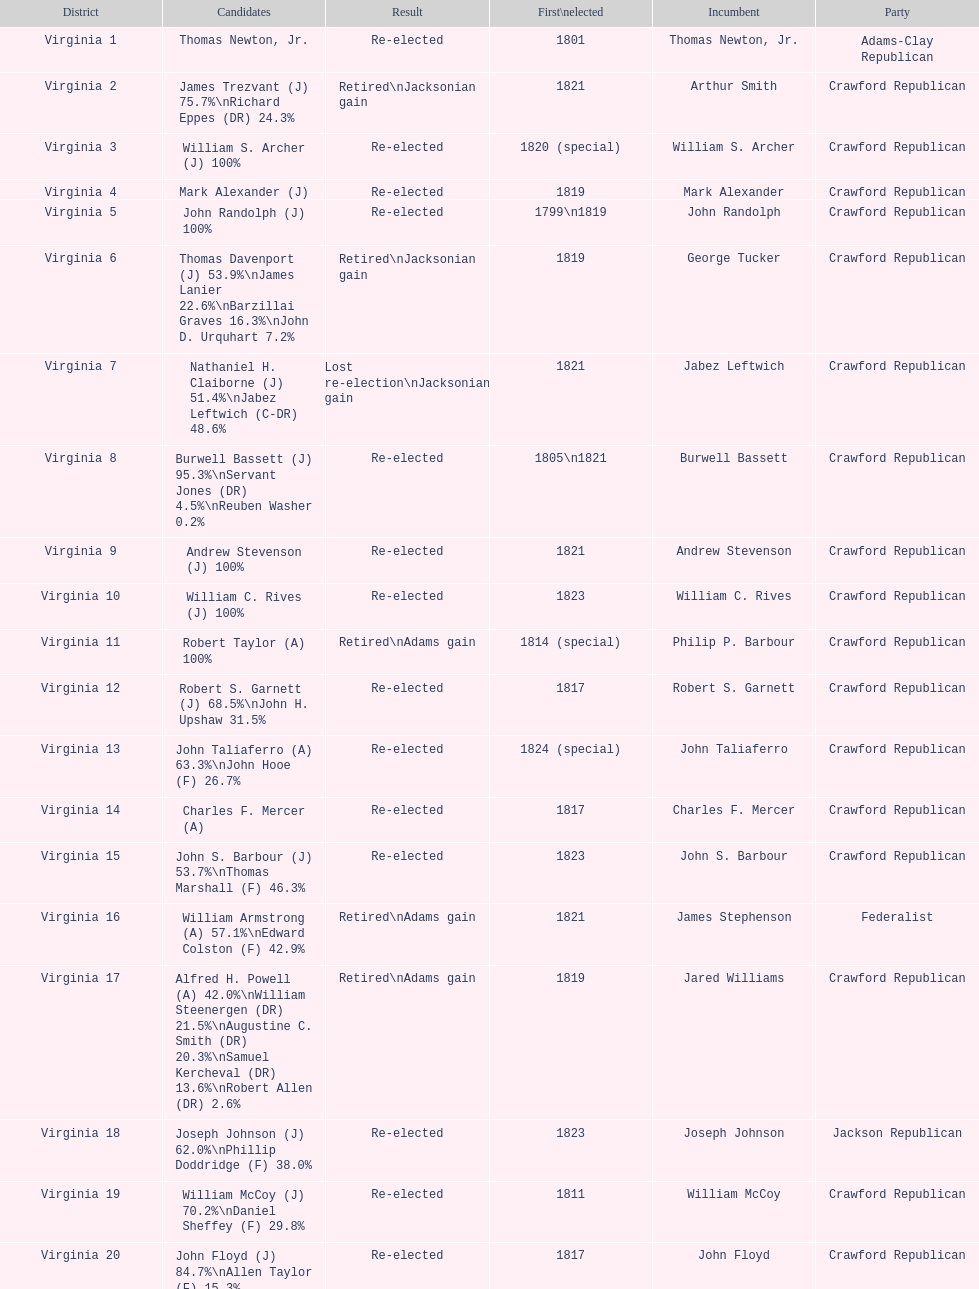Which jacksonian candidates got at least 76% of the vote in their races? Arthur Smith. 